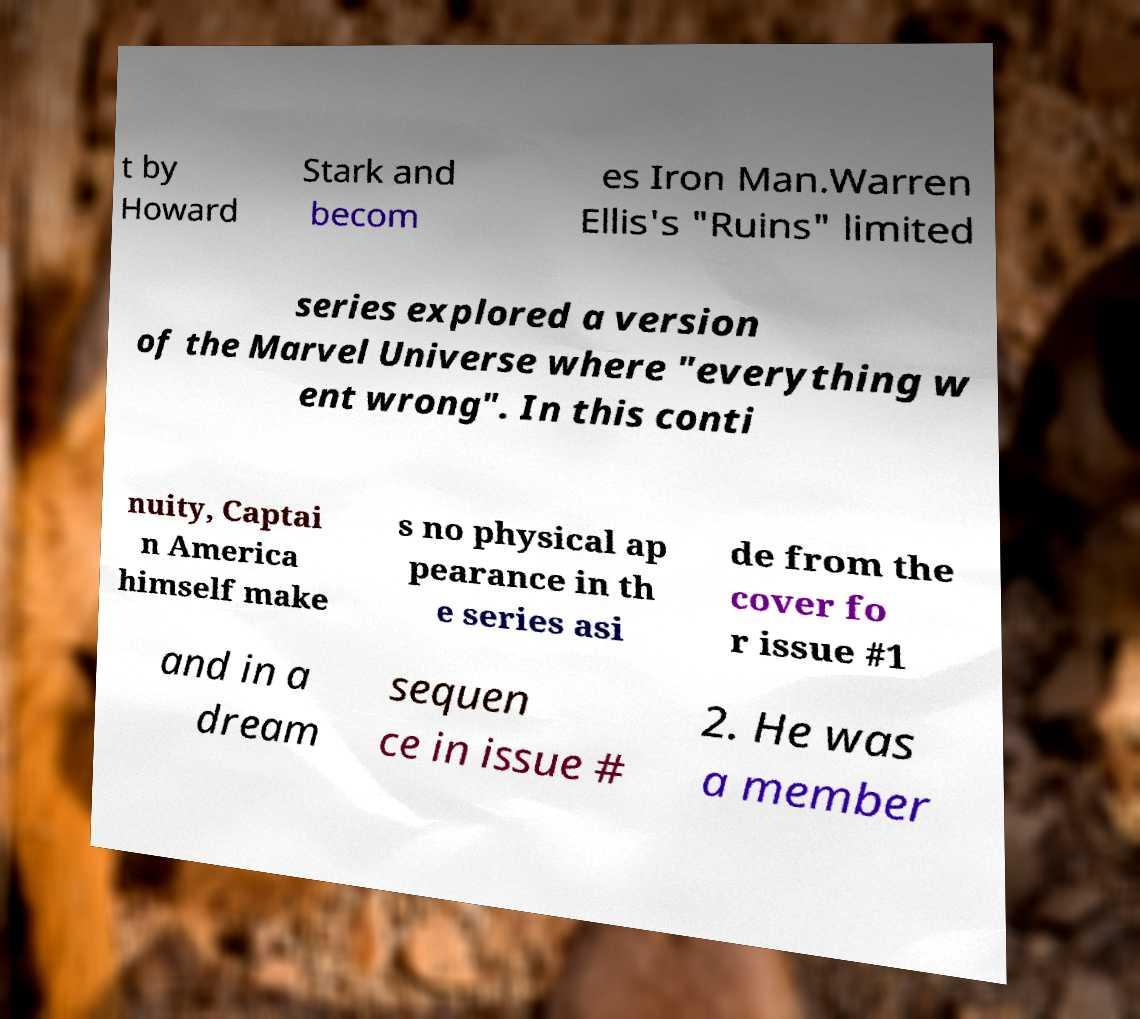I need the written content from this picture converted into text. Can you do that? t by Howard Stark and becom es Iron Man.Warren Ellis's "Ruins" limited series explored a version of the Marvel Universe where "everything w ent wrong". In this conti nuity, Captai n America himself make s no physical ap pearance in th e series asi de from the cover fo r issue #1 and in a dream sequen ce in issue # 2. He was a member 